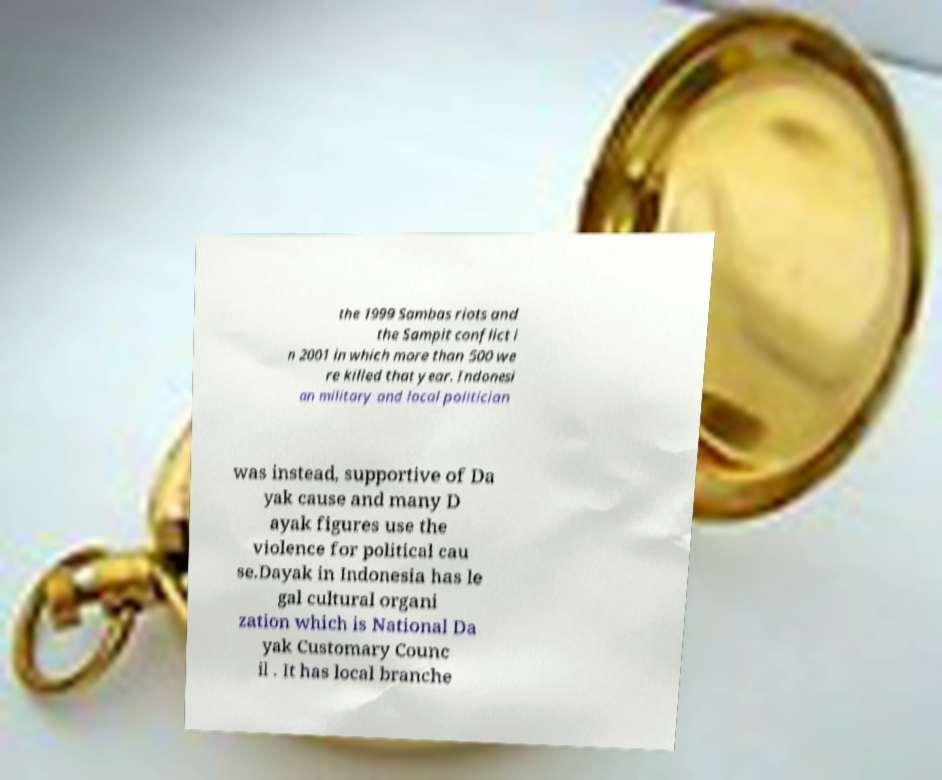Could you extract and type out the text from this image? the 1999 Sambas riots and the Sampit conflict i n 2001 in which more than 500 we re killed that year. Indonesi an military and local politician was instead, supportive of Da yak cause and many D ayak figures use the violence for political cau se.Dayak in Indonesia has le gal cultural organi zation which is National Da yak Customary Counc il . It has local branche 